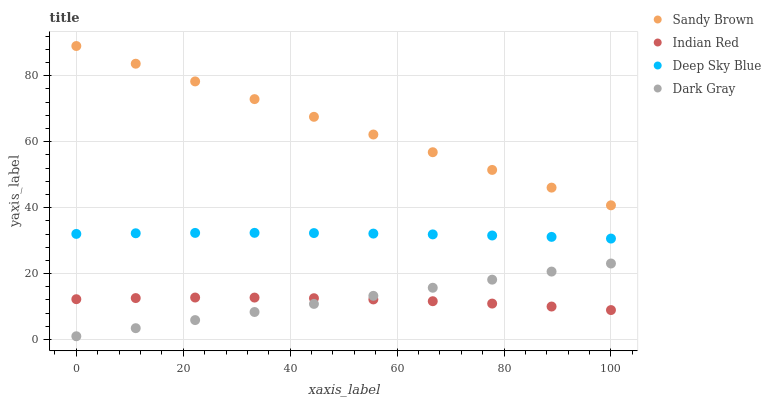Does Indian Red have the minimum area under the curve?
Answer yes or no. Yes. Does Sandy Brown have the maximum area under the curve?
Answer yes or no. Yes. Does Deep Sky Blue have the minimum area under the curve?
Answer yes or no. No. Does Deep Sky Blue have the maximum area under the curve?
Answer yes or no. No. Is Dark Gray the smoothest?
Answer yes or no. Yes. Is Indian Red the roughest?
Answer yes or no. Yes. Is Sandy Brown the smoothest?
Answer yes or no. No. Is Sandy Brown the roughest?
Answer yes or no. No. Does Dark Gray have the lowest value?
Answer yes or no. Yes. Does Deep Sky Blue have the lowest value?
Answer yes or no. No. Does Sandy Brown have the highest value?
Answer yes or no. Yes. Does Deep Sky Blue have the highest value?
Answer yes or no. No. Is Dark Gray less than Sandy Brown?
Answer yes or no. Yes. Is Deep Sky Blue greater than Dark Gray?
Answer yes or no. Yes. Does Indian Red intersect Dark Gray?
Answer yes or no. Yes. Is Indian Red less than Dark Gray?
Answer yes or no. No. Is Indian Red greater than Dark Gray?
Answer yes or no. No. Does Dark Gray intersect Sandy Brown?
Answer yes or no. No. 